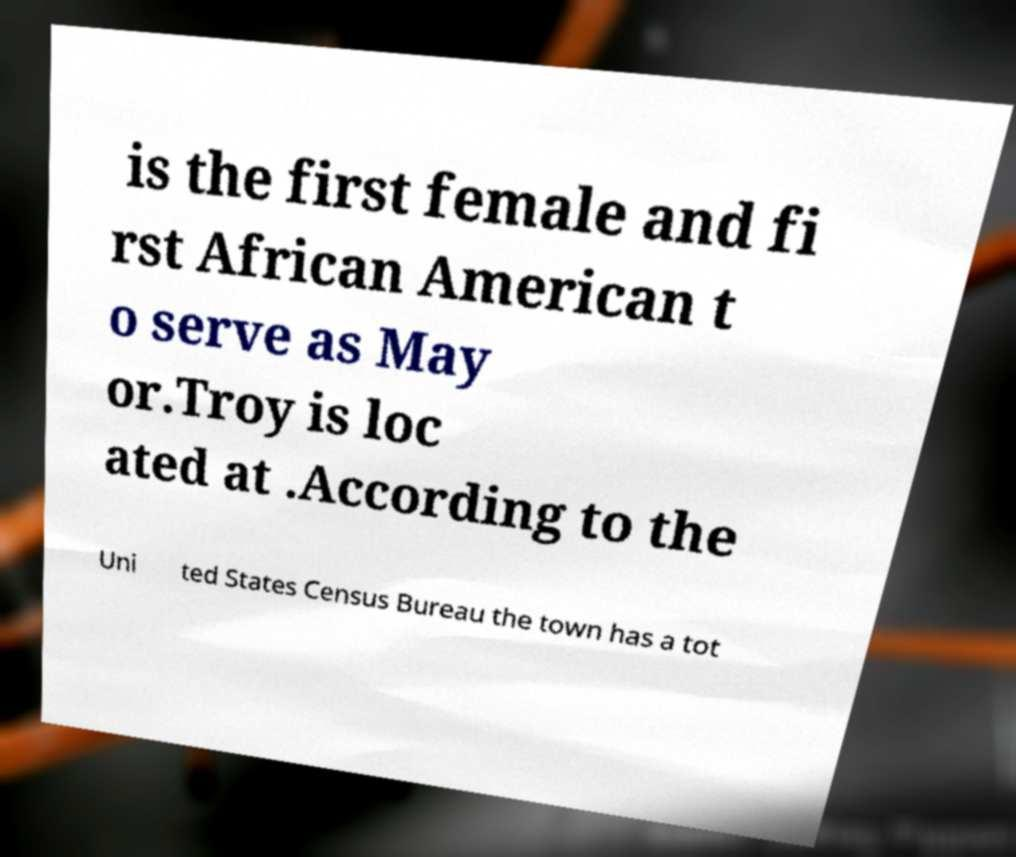Can you accurately transcribe the text from the provided image for me? is the first female and fi rst African American t o serve as May or.Troy is loc ated at .According to the Uni ted States Census Bureau the town has a tot 